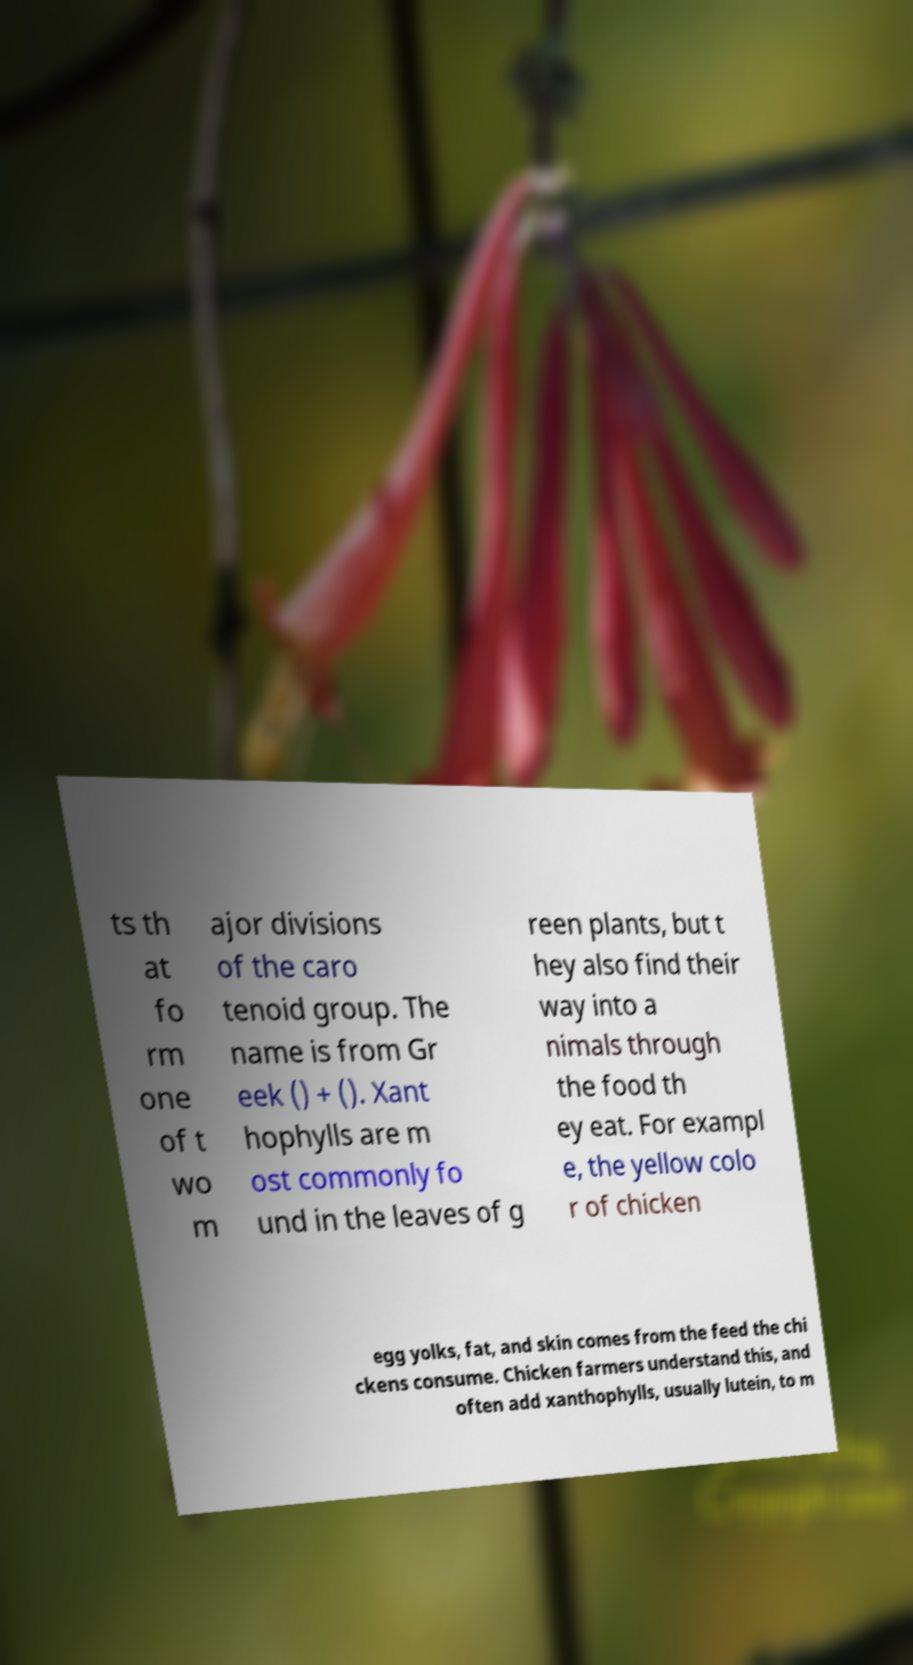For documentation purposes, I need the text within this image transcribed. Could you provide that? ts th at fo rm one of t wo m ajor divisions of the caro tenoid group. The name is from Gr eek () + (). Xant hophylls are m ost commonly fo und in the leaves of g reen plants, but t hey also find their way into a nimals through the food th ey eat. For exampl e, the yellow colo r of chicken egg yolks, fat, and skin comes from the feed the chi ckens consume. Chicken farmers understand this, and often add xanthophylls, usually lutein, to m 